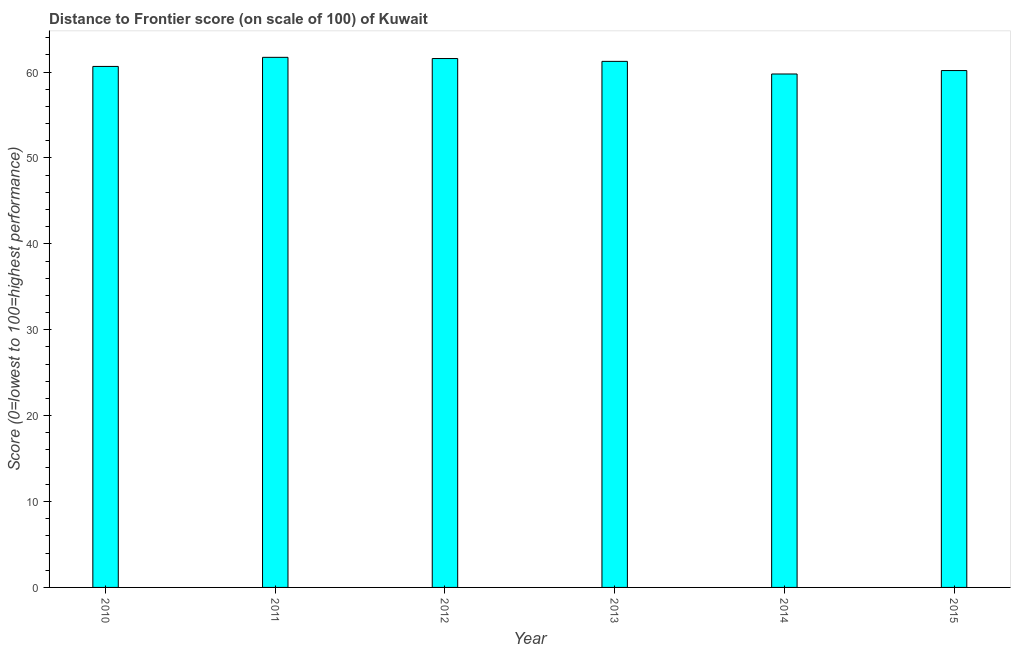Does the graph contain any zero values?
Your response must be concise. No. What is the title of the graph?
Give a very brief answer. Distance to Frontier score (on scale of 100) of Kuwait. What is the label or title of the Y-axis?
Provide a short and direct response. Score (0=lowest to 100=highest performance). What is the distance to frontier score in 2011?
Your answer should be very brief. 61.71. Across all years, what is the maximum distance to frontier score?
Your answer should be compact. 61.71. Across all years, what is the minimum distance to frontier score?
Your answer should be compact. 59.77. In which year was the distance to frontier score maximum?
Your answer should be compact. 2011. What is the sum of the distance to frontier score?
Offer a terse response. 365.11. What is the difference between the distance to frontier score in 2010 and 2015?
Provide a short and direct response. 0.48. What is the average distance to frontier score per year?
Offer a very short reply. 60.85. What is the median distance to frontier score?
Your answer should be very brief. 60.95. Do a majority of the years between 2015 and 2011 (inclusive) have distance to frontier score greater than 50 ?
Your answer should be very brief. Yes. Is the distance to frontier score in 2012 less than that in 2015?
Ensure brevity in your answer.  No. What is the difference between the highest and the second highest distance to frontier score?
Ensure brevity in your answer.  0.14. What is the difference between the highest and the lowest distance to frontier score?
Your answer should be very brief. 1.94. Are all the bars in the graph horizontal?
Your answer should be compact. No. Are the values on the major ticks of Y-axis written in scientific E-notation?
Offer a very short reply. No. What is the Score (0=lowest to 100=highest performance) of 2010?
Your response must be concise. 60.65. What is the Score (0=lowest to 100=highest performance) of 2011?
Provide a short and direct response. 61.71. What is the Score (0=lowest to 100=highest performance) in 2012?
Keep it short and to the point. 61.57. What is the Score (0=lowest to 100=highest performance) in 2013?
Ensure brevity in your answer.  61.24. What is the Score (0=lowest to 100=highest performance) of 2014?
Offer a very short reply. 59.77. What is the Score (0=lowest to 100=highest performance) in 2015?
Offer a terse response. 60.17. What is the difference between the Score (0=lowest to 100=highest performance) in 2010 and 2011?
Provide a succinct answer. -1.06. What is the difference between the Score (0=lowest to 100=highest performance) in 2010 and 2012?
Give a very brief answer. -0.92. What is the difference between the Score (0=lowest to 100=highest performance) in 2010 and 2013?
Your answer should be compact. -0.59. What is the difference between the Score (0=lowest to 100=highest performance) in 2010 and 2015?
Offer a very short reply. 0.48. What is the difference between the Score (0=lowest to 100=highest performance) in 2011 and 2012?
Offer a very short reply. 0.14. What is the difference between the Score (0=lowest to 100=highest performance) in 2011 and 2013?
Your answer should be compact. 0.47. What is the difference between the Score (0=lowest to 100=highest performance) in 2011 and 2014?
Ensure brevity in your answer.  1.94. What is the difference between the Score (0=lowest to 100=highest performance) in 2011 and 2015?
Offer a very short reply. 1.54. What is the difference between the Score (0=lowest to 100=highest performance) in 2012 and 2013?
Ensure brevity in your answer.  0.33. What is the difference between the Score (0=lowest to 100=highest performance) in 2012 and 2014?
Ensure brevity in your answer.  1.8. What is the difference between the Score (0=lowest to 100=highest performance) in 2012 and 2015?
Give a very brief answer. 1.4. What is the difference between the Score (0=lowest to 100=highest performance) in 2013 and 2014?
Your answer should be very brief. 1.47. What is the difference between the Score (0=lowest to 100=highest performance) in 2013 and 2015?
Offer a very short reply. 1.07. What is the difference between the Score (0=lowest to 100=highest performance) in 2014 and 2015?
Offer a very short reply. -0.4. What is the ratio of the Score (0=lowest to 100=highest performance) in 2010 to that in 2011?
Make the answer very short. 0.98. What is the ratio of the Score (0=lowest to 100=highest performance) in 2010 to that in 2013?
Provide a short and direct response. 0.99. What is the ratio of the Score (0=lowest to 100=highest performance) in 2010 to that in 2014?
Your answer should be very brief. 1.01. What is the ratio of the Score (0=lowest to 100=highest performance) in 2010 to that in 2015?
Your response must be concise. 1.01. What is the ratio of the Score (0=lowest to 100=highest performance) in 2011 to that in 2014?
Ensure brevity in your answer.  1.03. What is the ratio of the Score (0=lowest to 100=highest performance) in 2011 to that in 2015?
Give a very brief answer. 1.03. What is the ratio of the Score (0=lowest to 100=highest performance) in 2012 to that in 2013?
Provide a succinct answer. 1. What is the ratio of the Score (0=lowest to 100=highest performance) in 2012 to that in 2014?
Keep it short and to the point. 1.03. What is the ratio of the Score (0=lowest to 100=highest performance) in 2012 to that in 2015?
Ensure brevity in your answer.  1.02. What is the ratio of the Score (0=lowest to 100=highest performance) in 2013 to that in 2015?
Give a very brief answer. 1.02. 